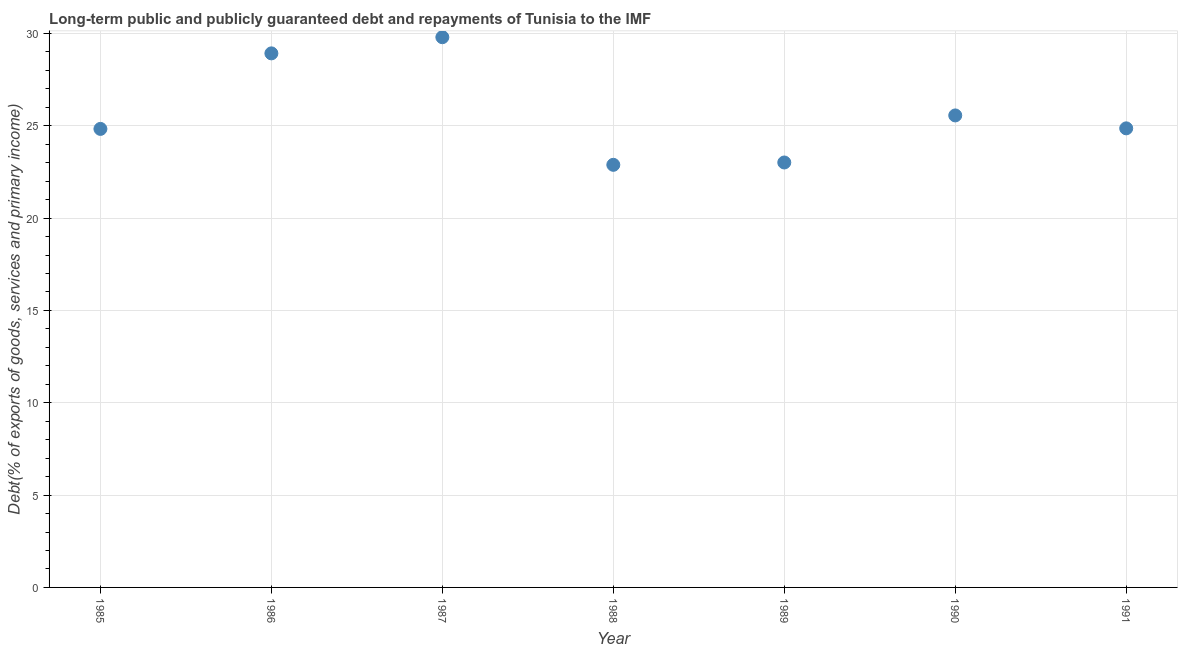What is the debt service in 1990?
Provide a short and direct response. 25.56. Across all years, what is the maximum debt service?
Provide a short and direct response. 29.79. Across all years, what is the minimum debt service?
Your answer should be very brief. 22.88. What is the sum of the debt service?
Offer a terse response. 179.86. What is the difference between the debt service in 1985 and 1989?
Offer a very short reply. 1.82. What is the average debt service per year?
Your response must be concise. 25.69. What is the median debt service?
Offer a very short reply. 24.86. Do a majority of the years between 1991 and 1988 (inclusive) have debt service greater than 9 %?
Make the answer very short. Yes. What is the ratio of the debt service in 1986 to that in 1990?
Your answer should be compact. 1.13. Is the debt service in 1989 less than that in 1991?
Offer a very short reply. Yes. What is the difference between the highest and the second highest debt service?
Ensure brevity in your answer.  0.88. What is the difference between the highest and the lowest debt service?
Provide a succinct answer. 6.91. In how many years, is the debt service greater than the average debt service taken over all years?
Provide a short and direct response. 2. Does the debt service monotonically increase over the years?
Your answer should be very brief. No. How many dotlines are there?
Offer a terse response. 1. Does the graph contain any zero values?
Ensure brevity in your answer.  No. Does the graph contain grids?
Your response must be concise. Yes. What is the title of the graph?
Provide a succinct answer. Long-term public and publicly guaranteed debt and repayments of Tunisia to the IMF. What is the label or title of the X-axis?
Offer a very short reply. Year. What is the label or title of the Y-axis?
Your answer should be very brief. Debt(% of exports of goods, services and primary income). What is the Debt(% of exports of goods, services and primary income) in 1985?
Your answer should be compact. 24.83. What is the Debt(% of exports of goods, services and primary income) in 1986?
Offer a very short reply. 28.92. What is the Debt(% of exports of goods, services and primary income) in 1987?
Make the answer very short. 29.79. What is the Debt(% of exports of goods, services and primary income) in 1988?
Provide a short and direct response. 22.88. What is the Debt(% of exports of goods, services and primary income) in 1989?
Offer a terse response. 23.01. What is the Debt(% of exports of goods, services and primary income) in 1990?
Keep it short and to the point. 25.56. What is the Debt(% of exports of goods, services and primary income) in 1991?
Your answer should be very brief. 24.86. What is the difference between the Debt(% of exports of goods, services and primary income) in 1985 and 1986?
Provide a succinct answer. -4.09. What is the difference between the Debt(% of exports of goods, services and primary income) in 1985 and 1987?
Make the answer very short. -4.97. What is the difference between the Debt(% of exports of goods, services and primary income) in 1985 and 1988?
Ensure brevity in your answer.  1.94. What is the difference between the Debt(% of exports of goods, services and primary income) in 1985 and 1989?
Provide a succinct answer. 1.82. What is the difference between the Debt(% of exports of goods, services and primary income) in 1985 and 1990?
Your answer should be very brief. -0.73. What is the difference between the Debt(% of exports of goods, services and primary income) in 1985 and 1991?
Offer a very short reply. -0.03. What is the difference between the Debt(% of exports of goods, services and primary income) in 1986 and 1987?
Ensure brevity in your answer.  -0.88. What is the difference between the Debt(% of exports of goods, services and primary income) in 1986 and 1988?
Keep it short and to the point. 6.04. What is the difference between the Debt(% of exports of goods, services and primary income) in 1986 and 1989?
Offer a terse response. 5.91. What is the difference between the Debt(% of exports of goods, services and primary income) in 1986 and 1990?
Offer a terse response. 3.36. What is the difference between the Debt(% of exports of goods, services and primary income) in 1986 and 1991?
Make the answer very short. 4.06. What is the difference between the Debt(% of exports of goods, services and primary income) in 1987 and 1988?
Ensure brevity in your answer.  6.91. What is the difference between the Debt(% of exports of goods, services and primary income) in 1987 and 1989?
Your answer should be very brief. 6.78. What is the difference between the Debt(% of exports of goods, services and primary income) in 1987 and 1990?
Offer a terse response. 4.24. What is the difference between the Debt(% of exports of goods, services and primary income) in 1987 and 1991?
Give a very brief answer. 4.94. What is the difference between the Debt(% of exports of goods, services and primary income) in 1988 and 1989?
Your answer should be very brief. -0.13. What is the difference between the Debt(% of exports of goods, services and primary income) in 1988 and 1990?
Ensure brevity in your answer.  -2.67. What is the difference between the Debt(% of exports of goods, services and primary income) in 1988 and 1991?
Keep it short and to the point. -1.97. What is the difference between the Debt(% of exports of goods, services and primary income) in 1989 and 1990?
Your response must be concise. -2.55. What is the difference between the Debt(% of exports of goods, services and primary income) in 1989 and 1991?
Your response must be concise. -1.85. What is the difference between the Debt(% of exports of goods, services and primary income) in 1990 and 1991?
Offer a terse response. 0.7. What is the ratio of the Debt(% of exports of goods, services and primary income) in 1985 to that in 1986?
Keep it short and to the point. 0.86. What is the ratio of the Debt(% of exports of goods, services and primary income) in 1985 to that in 1987?
Keep it short and to the point. 0.83. What is the ratio of the Debt(% of exports of goods, services and primary income) in 1985 to that in 1988?
Ensure brevity in your answer.  1.08. What is the ratio of the Debt(% of exports of goods, services and primary income) in 1985 to that in 1989?
Give a very brief answer. 1.08. What is the ratio of the Debt(% of exports of goods, services and primary income) in 1985 to that in 1990?
Keep it short and to the point. 0.97. What is the ratio of the Debt(% of exports of goods, services and primary income) in 1985 to that in 1991?
Provide a succinct answer. 1. What is the ratio of the Debt(% of exports of goods, services and primary income) in 1986 to that in 1987?
Give a very brief answer. 0.97. What is the ratio of the Debt(% of exports of goods, services and primary income) in 1986 to that in 1988?
Offer a very short reply. 1.26. What is the ratio of the Debt(% of exports of goods, services and primary income) in 1986 to that in 1989?
Offer a terse response. 1.26. What is the ratio of the Debt(% of exports of goods, services and primary income) in 1986 to that in 1990?
Make the answer very short. 1.13. What is the ratio of the Debt(% of exports of goods, services and primary income) in 1986 to that in 1991?
Offer a very short reply. 1.16. What is the ratio of the Debt(% of exports of goods, services and primary income) in 1987 to that in 1988?
Your response must be concise. 1.3. What is the ratio of the Debt(% of exports of goods, services and primary income) in 1987 to that in 1989?
Give a very brief answer. 1.29. What is the ratio of the Debt(% of exports of goods, services and primary income) in 1987 to that in 1990?
Your answer should be compact. 1.17. What is the ratio of the Debt(% of exports of goods, services and primary income) in 1987 to that in 1991?
Give a very brief answer. 1.2. What is the ratio of the Debt(% of exports of goods, services and primary income) in 1988 to that in 1990?
Offer a very short reply. 0.9. What is the ratio of the Debt(% of exports of goods, services and primary income) in 1988 to that in 1991?
Offer a terse response. 0.92. What is the ratio of the Debt(% of exports of goods, services and primary income) in 1989 to that in 1990?
Make the answer very short. 0.9. What is the ratio of the Debt(% of exports of goods, services and primary income) in 1989 to that in 1991?
Offer a terse response. 0.93. What is the ratio of the Debt(% of exports of goods, services and primary income) in 1990 to that in 1991?
Provide a short and direct response. 1.03. 